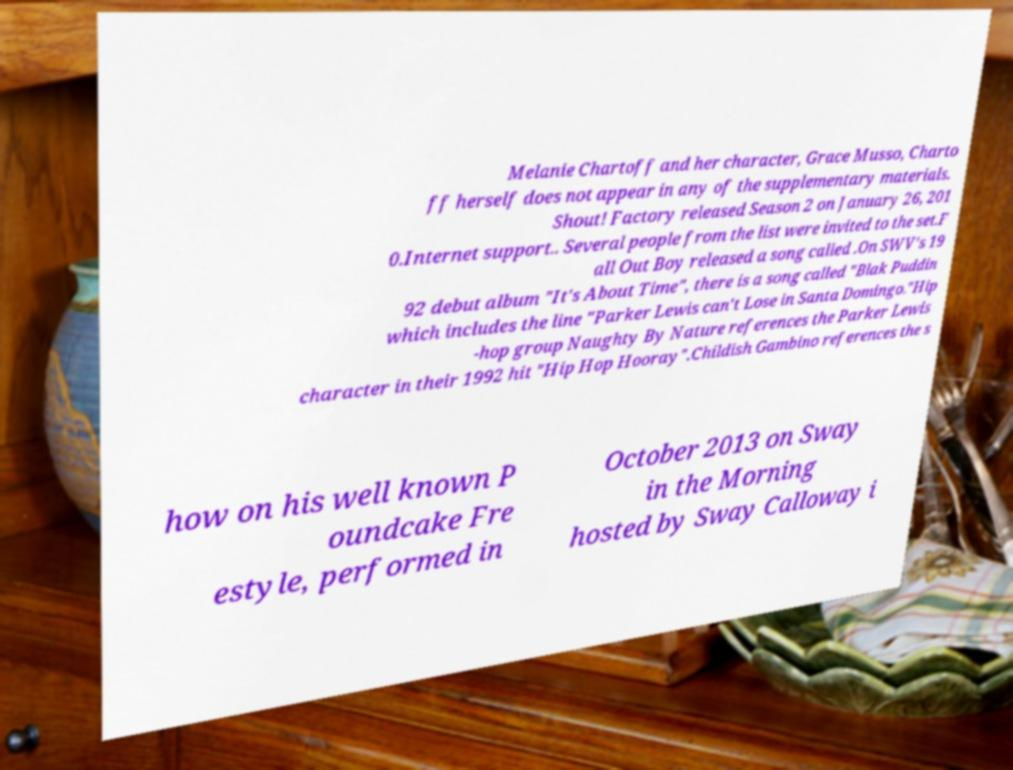Could you extract and type out the text from this image? Melanie Chartoff and her character, Grace Musso, Charto ff herself does not appear in any of the supplementary materials. Shout! Factory released Season 2 on January 26, 201 0.Internet support.. Several people from the list were invited to the set.F all Out Boy released a song called .On SWV's 19 92 debut album "It's About Time", there is a song called "Blak Puddin which includes the line "Parker Lewis can't Lose in Santa Domingo."Hip -hop group Naughty By Nature references the Parker Lewis character in their 1992 hit "Hip Hop Hooray".Childish Gambino references the s how on his well known P oundcake Fre estyle, performed in October 2013 on Sway in the Morning hosted by Sway Calloway i 